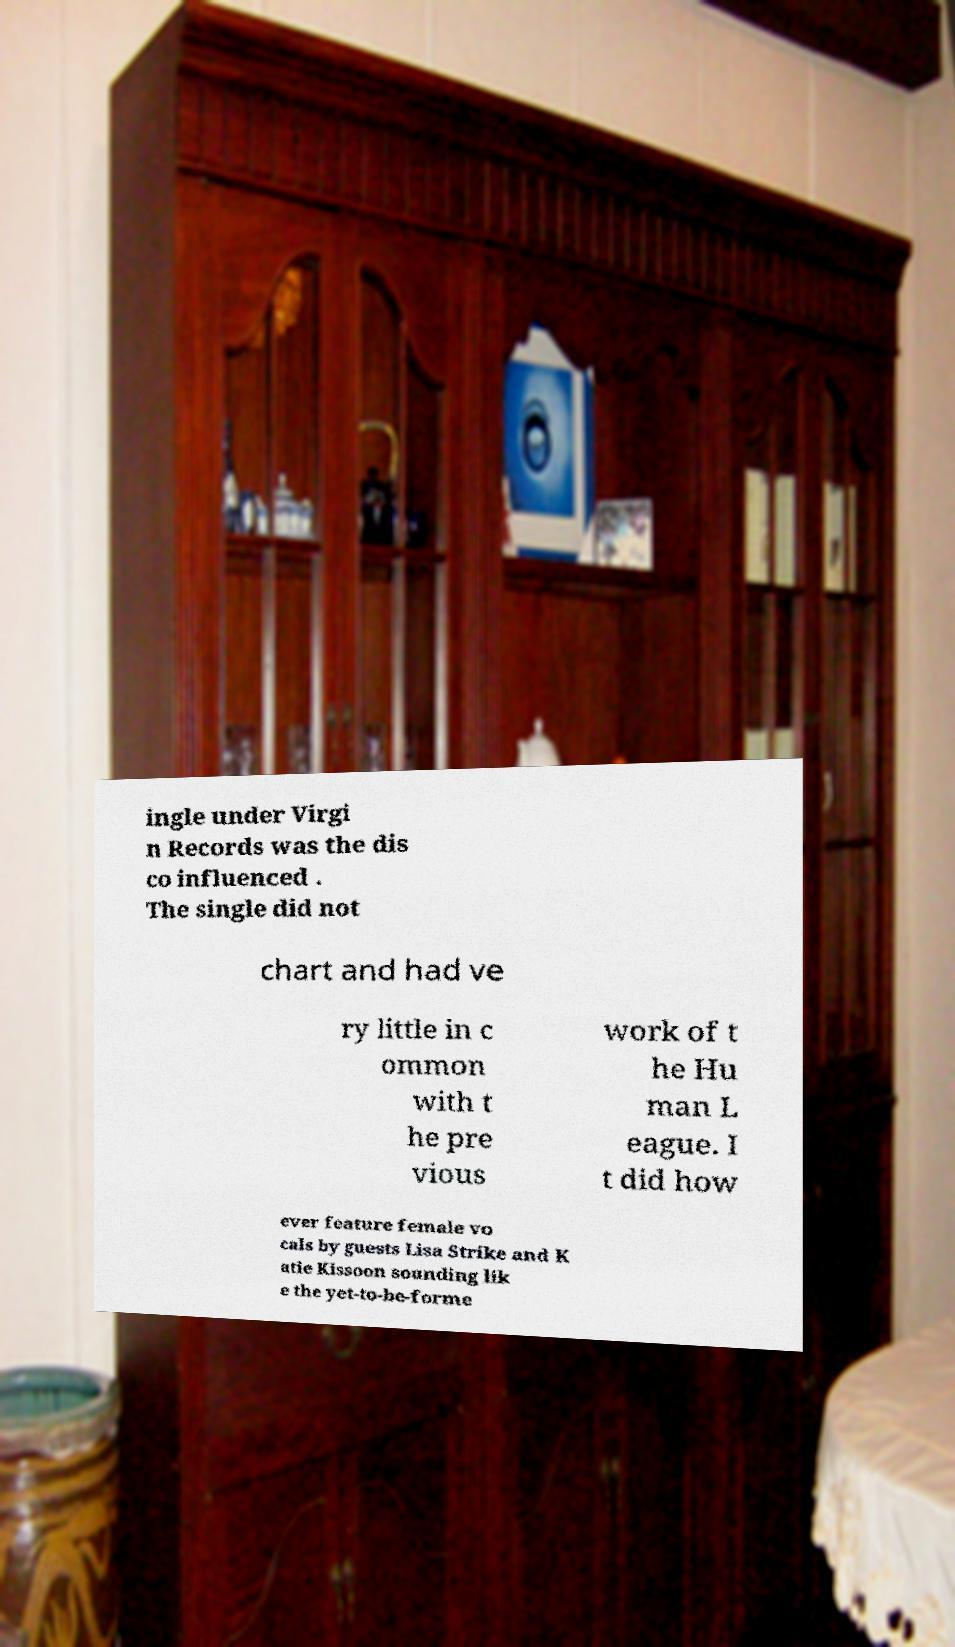I need the written content from this picture converted into text. Can you do that? ingle under Virgi n Records was the dis co influenced . The single did not chart and had ve ry little in c ommon with t he pre vious work of t he Hu man L eague. I t did how ever feature female vo cals by guests Lisa Strike and K atie Kissoon sounding lik e the yet-to-be-forme 